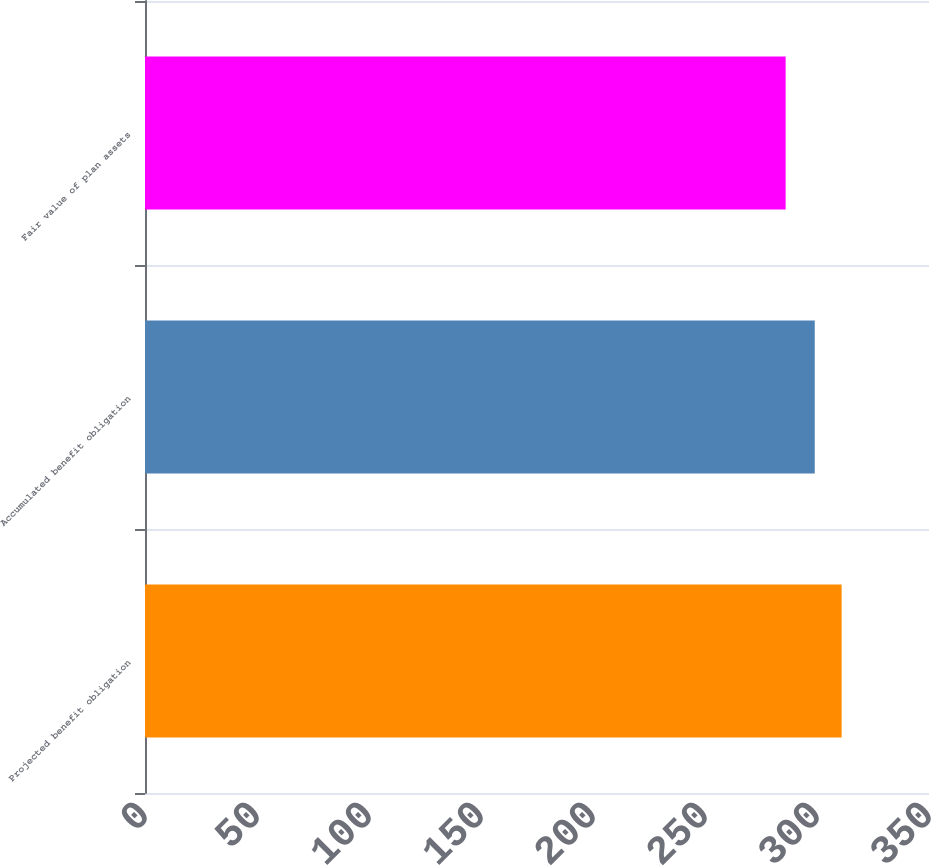Convert chart. <chart><loc_0><loc_0><loc_500><loc_500><bar_chart><fcel>Projected benefit obligation<fcel>Accumulated benefit obligation<fcel>Fair value of plan assets<nl><fcel>311<fcel>299<fcel>286<nl></chart> 